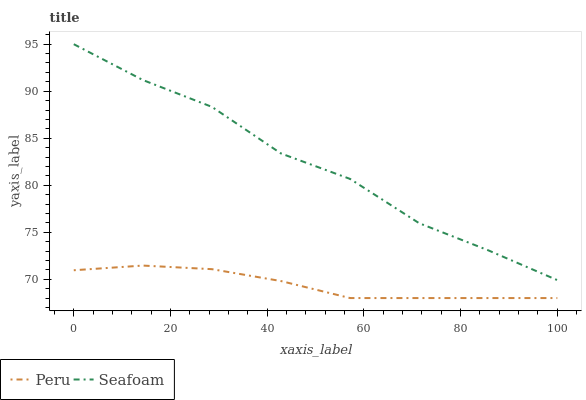Does Peru have the maximum area under the curve?
Answer yes or no. No. Is Peru the roughest?
Answer yes or no. No. Does Peru have the highest value?
Answer yes or no. No. Is Peru less than Seafoam?
Answer yes or no. Yes. Is Seafoam greater than Peru?
Answer yes or no. Yes. Does Peru intersect Seafoam?
Answer yes or no. No. 